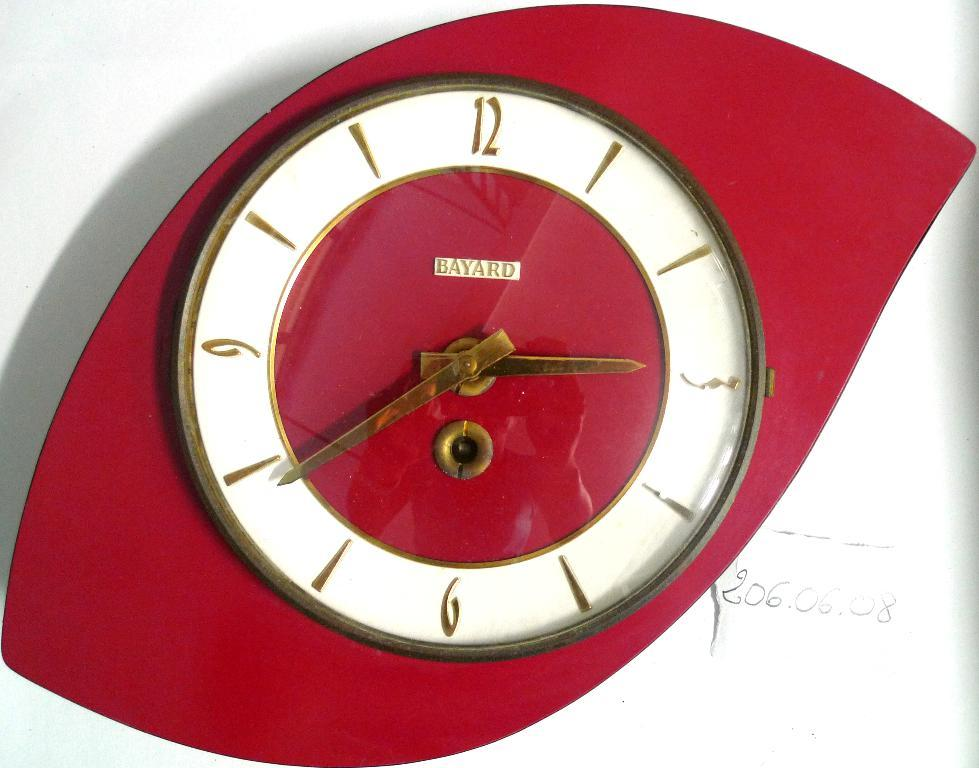<image>
Create a compact narrative representing the image presented. An Art Deco looking clock that says Bayard on it. 